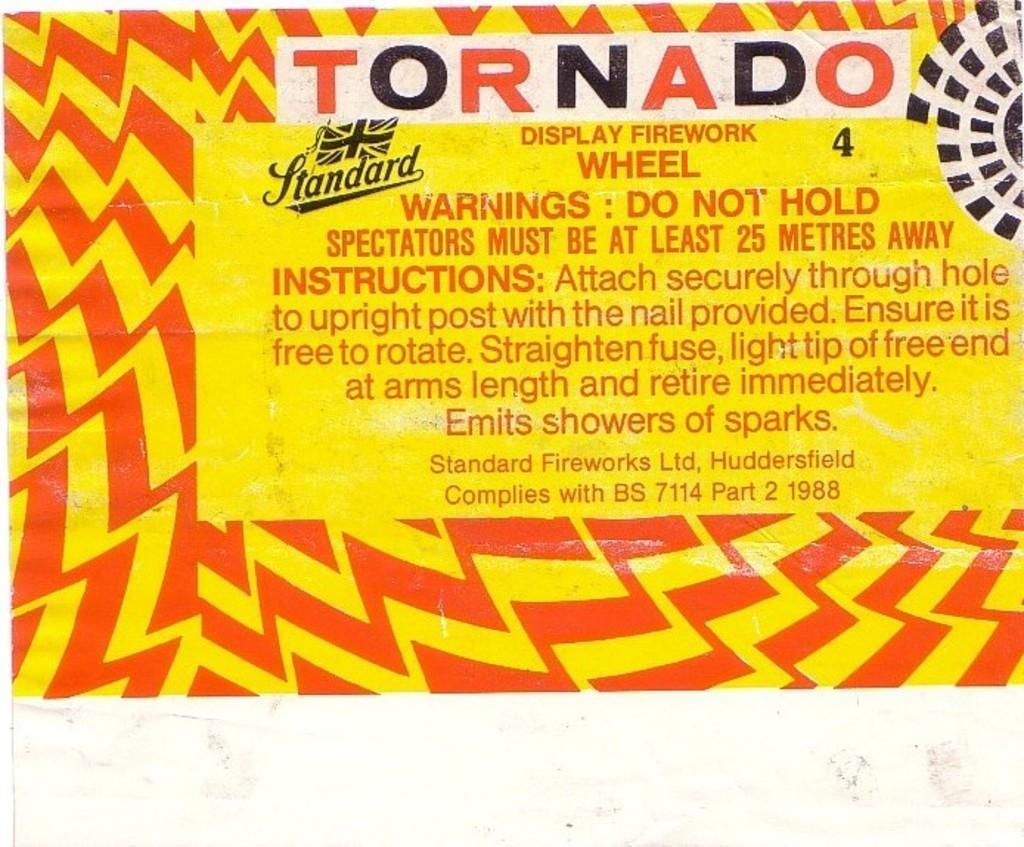Please provide a concise description of this image. In this image we can see the advertisement. 